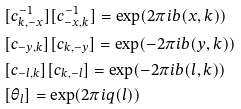<formula> <loc_0><loc_0><loc_500><loc_500>& [ c ^ { - 1 } _ { k , - x } ] [ c ^ { - 1 } _ { - x , k } ] = \text {exp} ( 2 \pi i b ( x , k ) ) \\ & [ c _ { - y , k } ] [ c _ { k , - y } ] = \text {exp} ( - 2 \pi i b ( y , k ) ) \\ & [ c _ { - l , k } ] [ c _ { k , - l } ] = \text {exp} ( - 2 \pi i b ( l , k ) ) \\ & [ \theta _ { l } ] = \text {exp} ( 2 \pi i q ( l ) )</formula> 